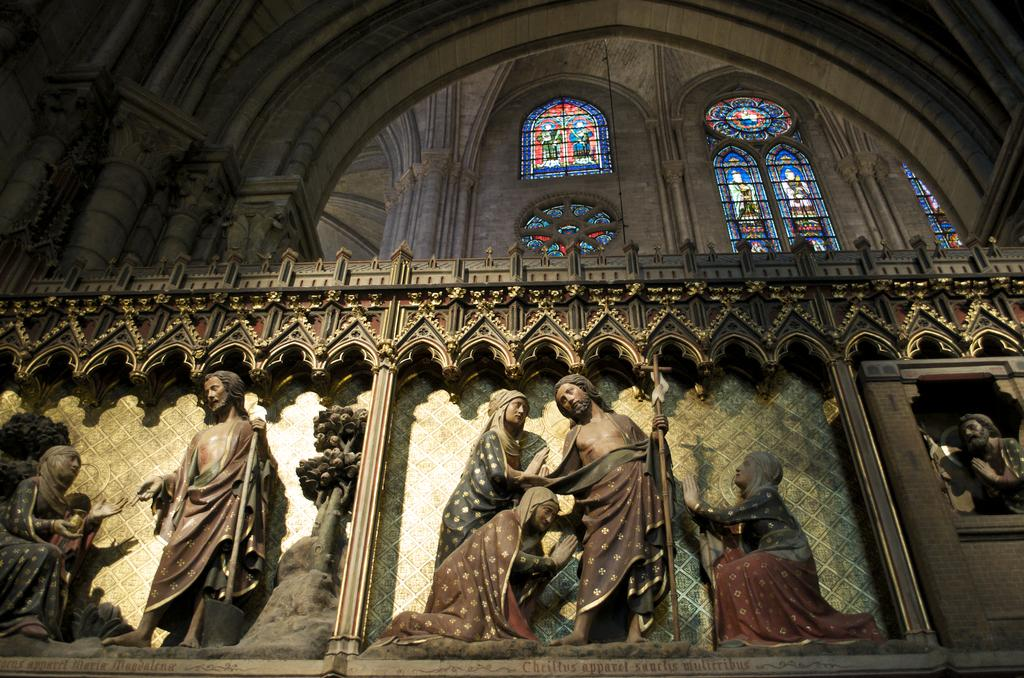What is the main structure in the center of the image? There is a building in the center of the image. What type of architectural feature can be seen in the image? There is a wall in the image. What material is used for the glass in the image? Glass is present in the image. What type of artwork is visible in the image? There are sculptures in the image. What kind of design is on the wall in the image? There is a design on the wall in the image. What type of shoes can be seen hanging from the wing in the image? There is no wing or shoes present in the image. How many baskets are hanging from the sculptures in the image? There are no baskets present in the image. 